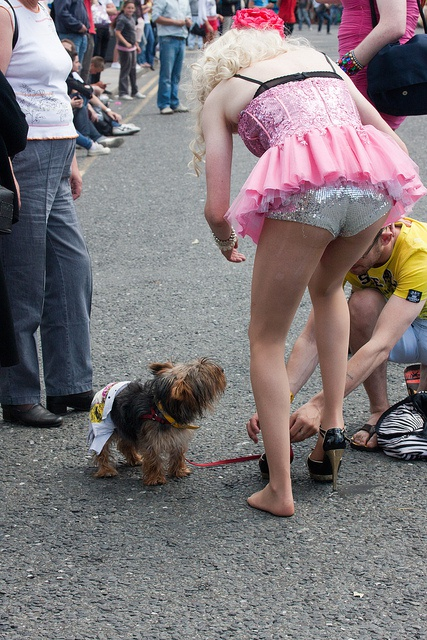Describe the objects in this image and their specific colors. I can see people in lavender, brown, darkgray, and gray tones, people in lavender, black, and gray tones, people in lavender, darkgray, gray, and maroon tones, dog in lavender, black, gray, and maroon tones, and people in lavender, purple, pink, and black tones in this image. 